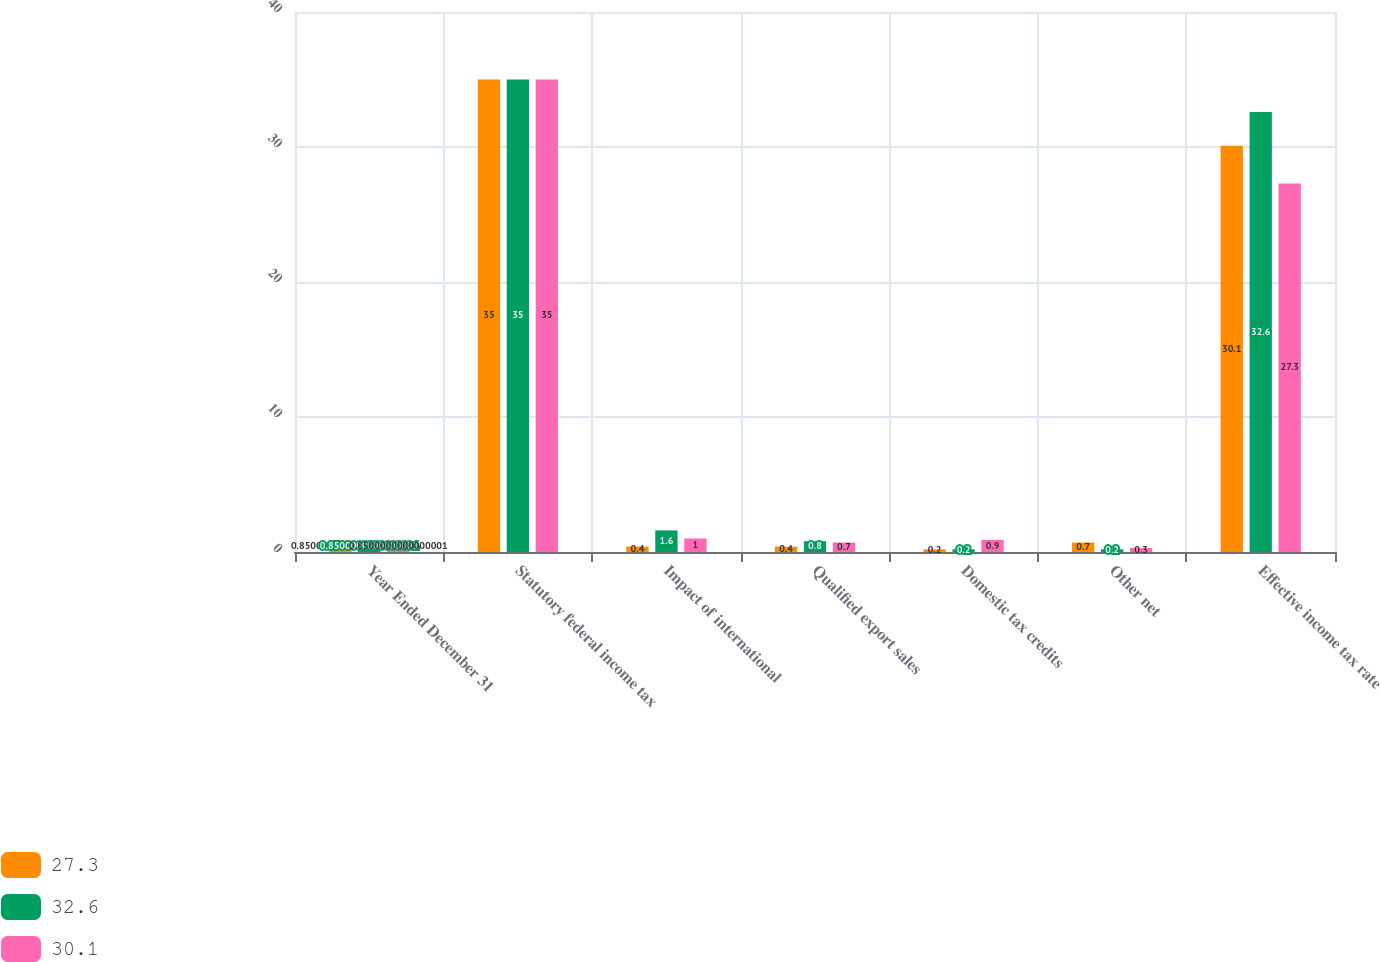<chart> <loc_0><loc_0><loc_500><loc_500><stacked_bar_chart><ecel><fcel>Year Ended December 31<fcel>Statutory federal income tax<fcel>Impact of international<fcel>Qualified export sales<fcel>Domestic tax credits<fcel>Other net<fcel>Effective income tax rate<nl><fcel>27.3<fcel>0.85<fcel>35<fcel>0.4<fcel>0.4<fcel>0.2<fcel>0.7<fcel>30.1<nl><fcel>32.6<fcel>0.85<fcel>35<fcel>1.6<fcel>0.8<fcel>0.2<fcel>0.2<fcel>32.6<nl><fcel>30.1<fcel>0.85<fcel>35<fcel>1<fcel>0.7<fcel>0.9<fcel>0.3<fcel>27.3<nl></chart> 